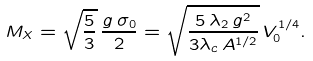<formula> <loc_0><loc_0><loc_500><loc_500>M _ { X } = \sqrt { \frac { 5 } { 3 } } \, \frac { g \, \sigma _ { 0 } } { 2 } = \sqrt { \frac { 5 \, \lambda _ { 2 } \, g ^ { 2 } } { 3 \lambda _ { c } \, A ^ { 1 / 2 } } } \, V _ { 0 } ^ { 1 / 4 } .</formula> 